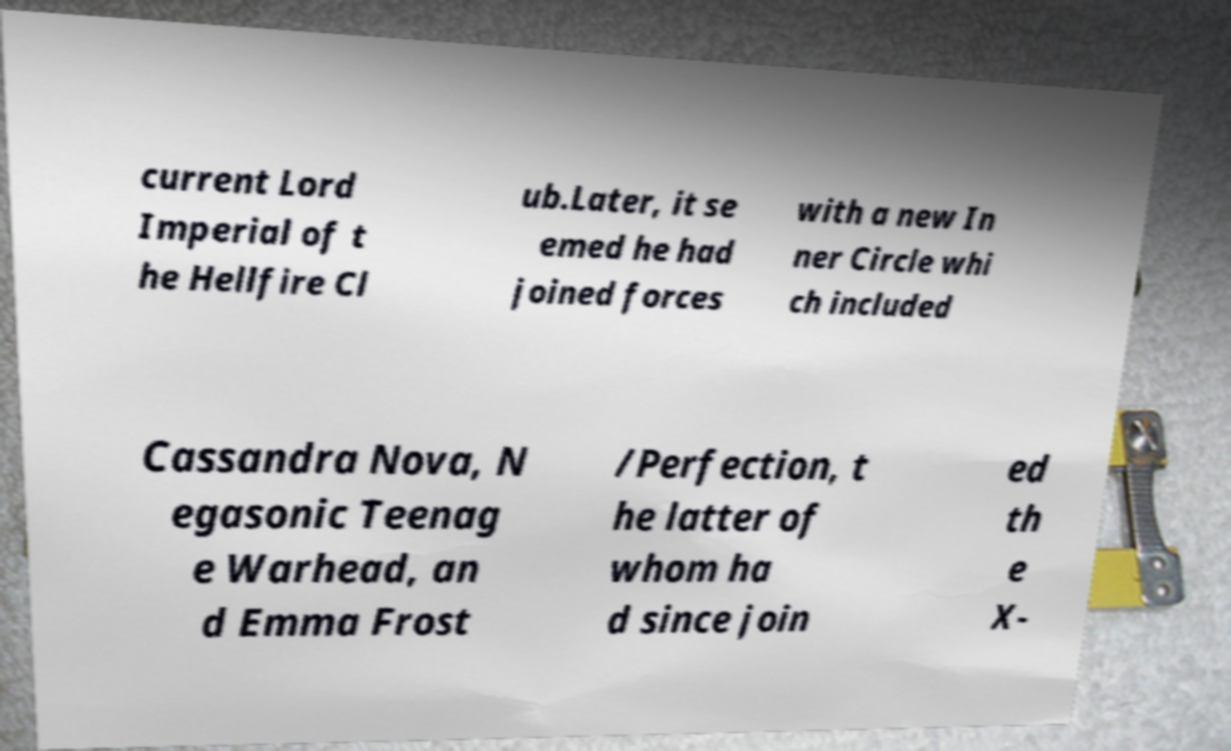Could you extract and type out the text from this image? current Lord Imperial of t he Hellfire Cl ub.Later, it se emed he had joined forces with a new In ner Circle whi ch included Cassandra Nova, N egasonic Teenag e Warhead, an d Emma Frost /Perfection, t he latter of whom ha d since join ed th e X- 